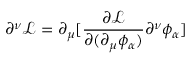Convert formula to latex. <formula><loc_0><loc_0><loc_500><loc_500>\partial ^ { \nu } { \mathcal { L } } = \partial _ { \mu } [ { \frac { \partial { \mathcal { L } } } { \partial ( \partial _ { \mu } \phi _ { \alpha } ) } } \partial ^ { \nu } \phi _ { \alpha } ]</formula> 